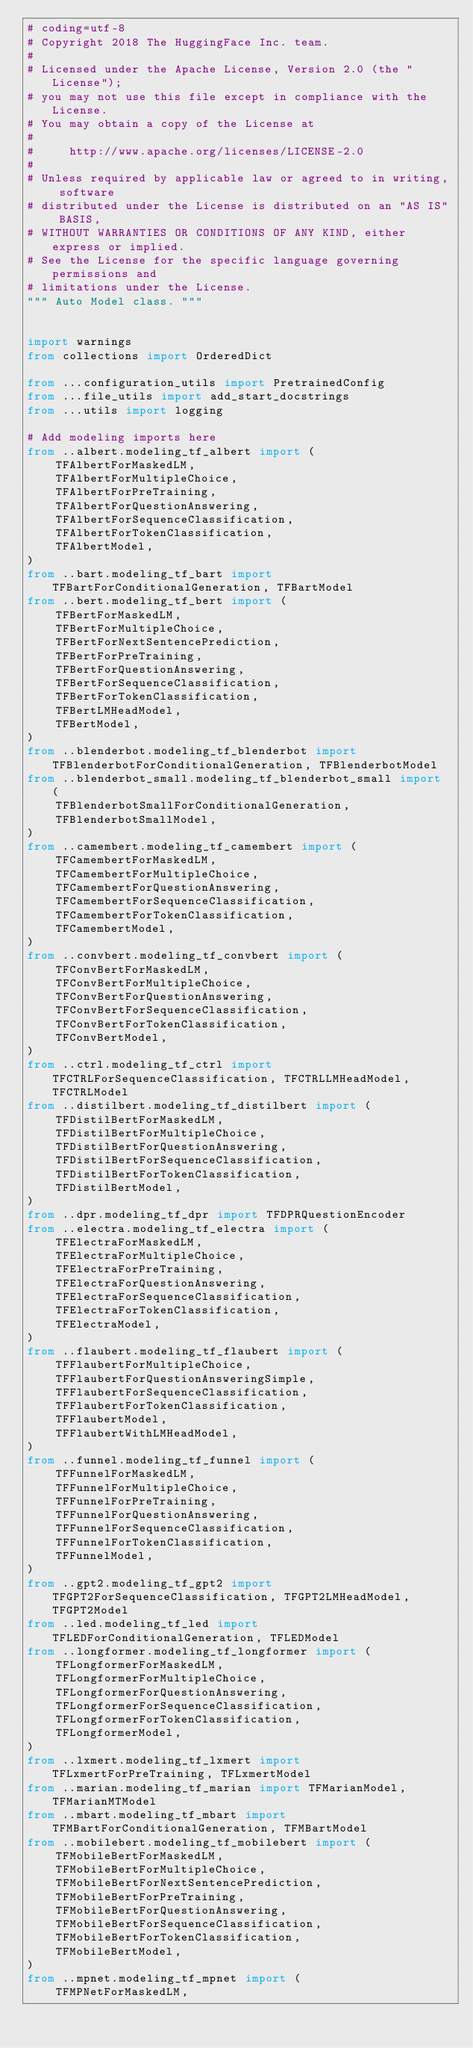<code> <loc_0><loc_0><loc_500><loc_500><_Python_># coding=utf-8
# Copyright 2018 The HuggingFace Inc. team.
#
# Licensed under the Apache License, Version 2.0 (the "License");
# you may not use this file except in compliance with the License.
# You may obtain a copy of the License at
#
#     http://www.apache.org/licenses/LICENSE-2.0
#
# Unless required by applicable law or agreed to in writing, software
# distributed under the License is distributed on an "AS IS" BASIS,
# WITHOUT WARRANTIES OR CONDITIONS OF ANY KIND, either express or implied.
# See the License for the specific language governing permissions and
# limitations under the License.
""" Auto Model class. """


import warnings
from collections import OrderedDict

from ...configuration_utils import PretrainedConfig
from ...file_utils import add_start_docstrings
from ...utils import logging

# Add modeling imports here
from ..albert.modeling_tf_albert import (
    TFAlbertForMaskedLM,
    TFAlbertForMultipleChoice,
    TFAlbertForPreTraining,
    TFAlbertForQuestionAnswering,
    TFAlbertForSequenceClassification,
    TFAlbertForTokenClassification,
    TFAlbertModel,
)
from ..bart.modeling_tf_bart import TFBartForConditionalGeneration, TFBartModel
from ..bert.modeling_tf_bert import (
    TFBertForMaskedLM,
    TFBertForMultipleChoice,
    TFBertForNextSentencePrediction,
    TFBertForPreTraining,
    TFBertForQuestionAnswering,
    TFBertForSequenceClassification,
    TFBertForTokenClassification,
    TFBertLMHeadModel,
    TFBertModel,
)
from ..blenderbot.modeling_tf_blenderbot import TFBlenderbotForConditionalGeneration, TFBlenderbotModel
from ..blenderbot_small.modeling_tf_blenderbot_small import (
    TFBlenderbotSmallForConditionalGeneration,
    TFBlenderbotSmallModel,
)
from ..camembert.modeling_tf_camembert import (
    TFCamembertForMaskedLM,
    TFCamembertForMultipleChoice,
    TFCamembertForQuestionAnswering,
    TFCamembertForSequenceClassification,
    TFCamembertForTokenClassification,
    TFCamembertModel,
)
from ..convbert.modeling_tf_convbert import (
    TFConvBertForMaskedLM,
    TFConvBertForMultipleChoice,
    TFConvBertForQuestionAnswering,
    TFConvBertForSequenceClassification,
    TFConvBertForTokenClassification,
    TFConvBertModel,
)
from ..ctrl.modeling_tf_ctrl import TFCTRLForSequenceClassification, TFCTRLLMHeadModel, TFCTRLModel
from ..distilbert.modeling_tf_distilbert import (
    TFDistilBertForMaskedLM,
    TFDistilBertForMultipleChoice,
    TFDistilBertForQuestionAnswering,
    TFDistilBertForSequenceClassification,
    TFDistilBertForTokenClassification,
    TFDistilBertModel,
)
from ..dpr.modeling_tf_dpr import TFDPRQuestionEncoder
from ..electra.modeling_tf_electra import (
    TFElectraForMaskedLM,
    TFElectraForMultipleChoice,
    TFElectraForPreTraining,
    TFElectraForQuestionAnswering,
    TFElectraForSequenceClassification,
    TFElectraForTokenClassification,
    TFElectraModel,
)
from ..flaubert.modeling_tf_flaubert import (
    TFFlaubertForMultipleChoice,
    TFFlaubertForQuestionAnsweringSimple,
    TFFlaubertForSequenceClassification,
    TFFlaubertForTokenClassification,
    TFFlaubertModel,
    TFFlaubertWithLMHeadModel,
)
from ..funnel.modeling_tf_funnel import (
    TFFunnelForMaskedLM,
    TFFunnelForMultipleChoice,
    TFFunnelForPreTraining,
    TFFunnelForQuestionAnswering,
    TFFunnelForSequenceClassification,
    TFFunnelForTokenClassification,
    TFFunnelModel,
)
from ..gpt2.modeling_tf_gpt2 import TFGPT2ForSequenceClassification, TFGPT2LMHeadModel, TFGPT2Model
from ..led.modeling_tf_led import TFLEDForConditionalGeneration, TFLEDModel
from ..longformer.modeling_tf_longformer import (
    TFLongformerForMaskedLM,
    TFLongformerForMultipleChoice,
    TFLongformerForQuestionAnswering,
    TFLongformerForSequenceClassification,
    TFLongformerForTokenClassification,
    TFLongformerModel,
)
from ..lxmert.modeling_tf_lxmert import TFLxmertForPreTraining, TFLxmertModel
from ..marian.modeling_tf_marian import TFMarianModel, TFMarianMTModel
from ..mbart.modeling_tf_mbart import TFMBartForConditionalGeneration, TFMBartModel
from ..mobilebert.modeling_tf_mobilebert import (
    TFMobileBertForMaskedLM,
    TFMobileBertForMultipleChoice,
    TFMobileBertForNextSentencePrediction,
    TFMobileBertForPreTraining,
    TFMobileBertForQuestionAnswering,
    TFMobileBertForSequenceClassification,
    TFMobileBertForTokenClassification,
    TFMobileBertModel,
)
from ..mpnet.modeling_tf_mpnet import (
    TFMPNetForMaskedLM,</code> 